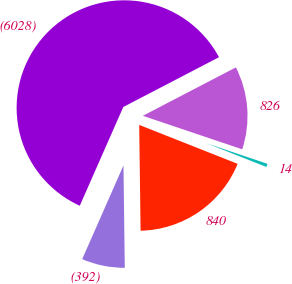<chart> <loc_0><loc_0><loc_500><loc_500><pie_chart><fcel>(6028)<fcel>(392)<fcel>840<fcel>14<fcel>826<nl><fcel>60.76%<fcel>6.81%<fcel>18.8%<fcel>0.82%<fcel>12.81%<nl></chart> 